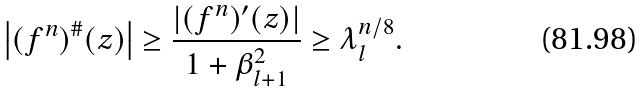<formula> <loc_0><loc_0><loc_500><loc_500>\left | ( f ^ { n } ) ^ { \# } ( z ) \right | \geq \frac { \left | ( f ^ { n } ) ^ { \prime } ( z ) \right | } { 1 + \beta _ { l + 1 } ^ { 2 } } \geq \lambda _ { l } ^ { n / 8 } .</formula> 